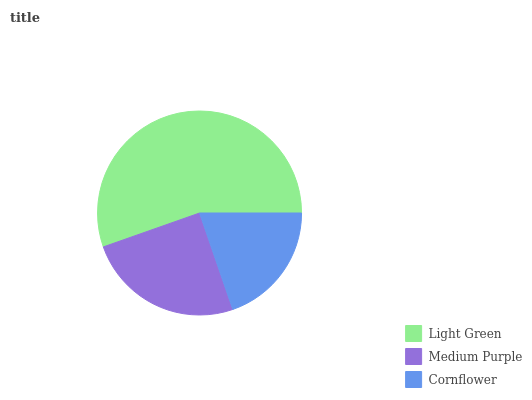Is Cornflower the minimum?
Answer yes or no. Yes. Is Light Green the maximum?
Answer yes or no. Yes. Is Medium Purple the minimum?
Answer yes or no. No. Is Medium Purple the maximum?
Answer yes or no. No. Is Light Green greater than Medium Purple?
Answer yes or no. Yes. Is Medium Purple less than Light Green?
Answer yes or no. Yes. Is Medium Purple greater than Light Green?
Answer yes or no. No. Is Light Green less than Medium Purple?
Answer yes or no. No. Is Medium Purple the high median?
Answer yes or no. Yes. Is Medium Purple the low median?
Answer yes or no. Yes. Is Cornflower the high median?
Answer yes or no. No. Is Cornflower the low median?
Answer yes or no. No. 